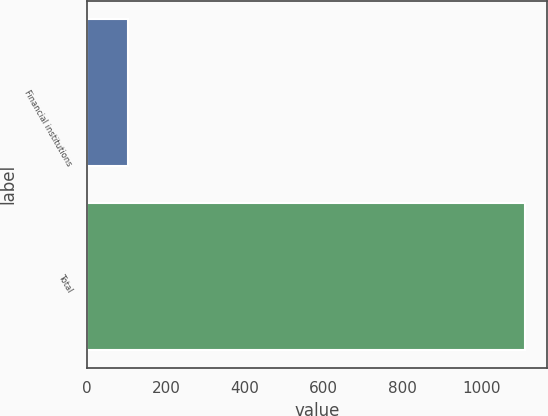Convert chart. <chart><loc_0><loc_0><loc_500><loc_500><bar_chart><fcel>Financial institutions<fcel>Total<nl><fcel>104.1<fcel>1111.7<nl></chart> 